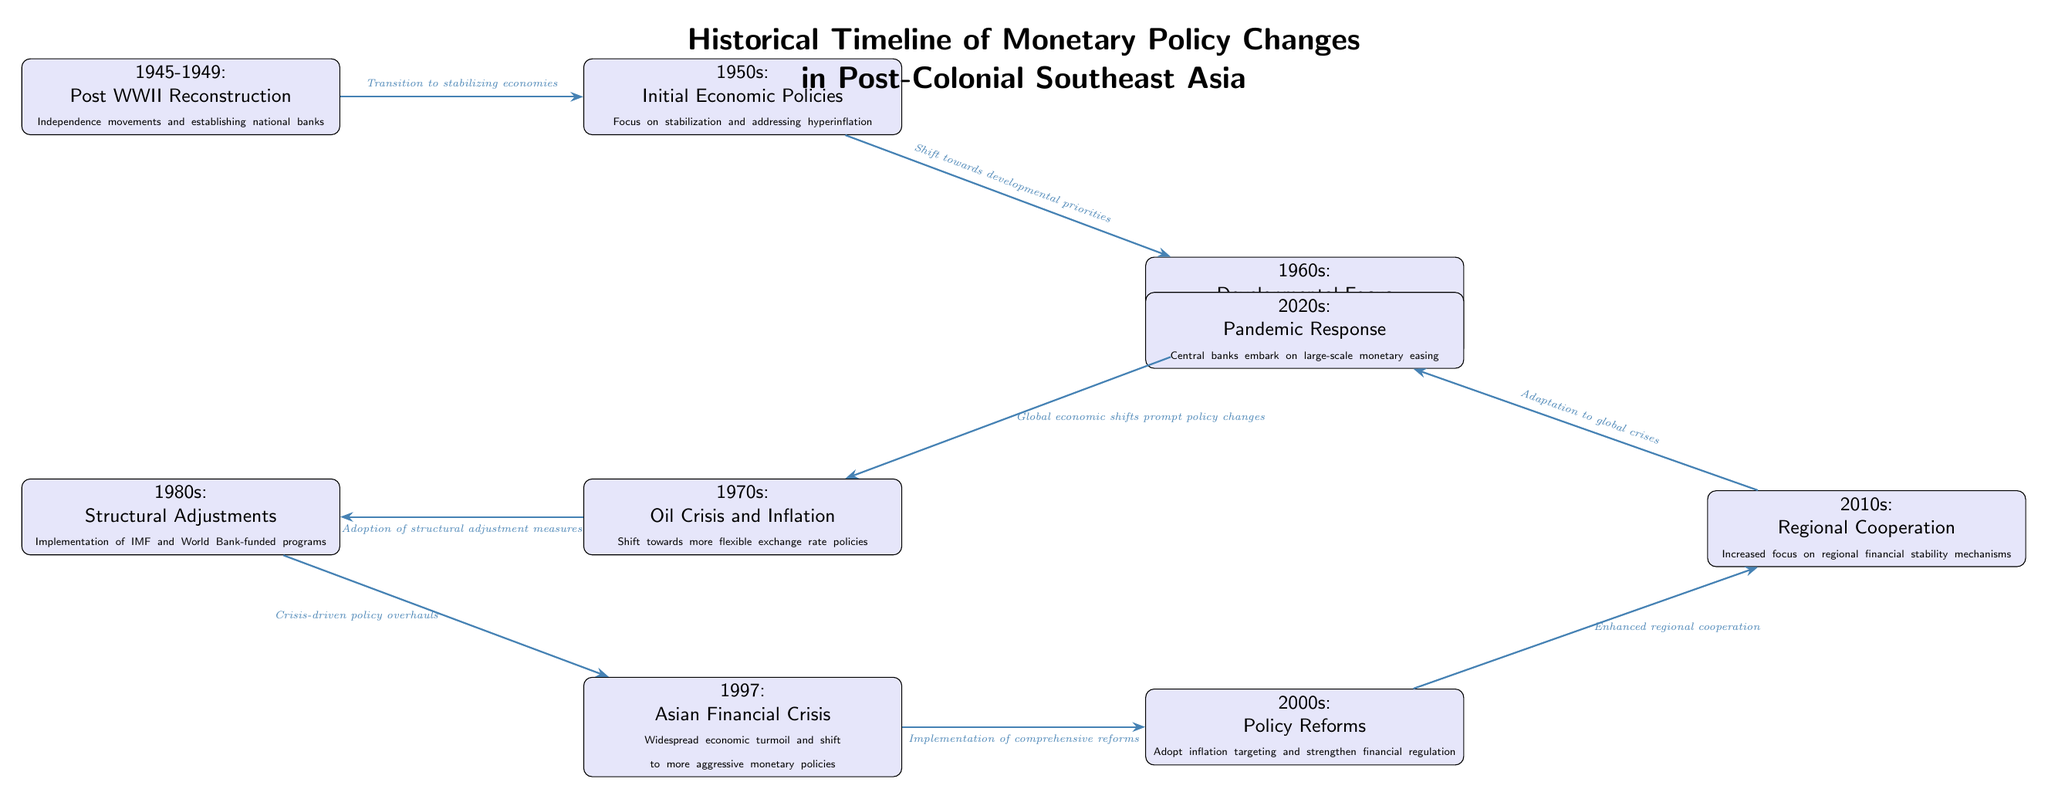What event marks the beginning of the timeline? The diagram starts with the period 1945-1949, labeled as "Post WWII Reconstruction" that discusses the independence movements and establishment of national banks.
Answer: 1945-1949 How many nodes are there in the diagram? The diagram contains a total of 9 nodes that represent different time periods and monetary policies.
Answer: 9 What was the focus of monetary policy in the 1980s? The node for the 1980s indicates "Structural Adjustments," highlighting the implementation of IMF and World Bank-funded programs as a key focus area.
Answer: Structural Adjustments Which event directly follows the Asian Financial Crisis in the timeline? The node for the Asian Financial Crisis (1997) is followed by the node for the 2000s, which emphasizes "Policy Reforms" including inflation targeting and strengthening financial regulation.
Answer: Policy Reforms What thematic shift occurs between the 1950s and 1960s? The transition from the 1950s to the 1960s shows a shift from "Initial Economic Policies" focusing on stabilization to a "Developmental Focus" aimed at supporting infrastructure through directed credit and fixed exchange rates.
Answer: Shift towards developmental priorities Which political and economic crisis is noted in the 1970s? The 1970s node discusses the "Oil Crisis and Inflation," indicating a significant crisis impacting economic policies during that period.
Answer: Oil Crisis and Inflation What connection is made between the 1997 financial crisis and policy changes? The diagram states that the Asian Financial Crisis led to "Crisis-driven policy overhauls," signifying a relationship between the crisis and subsequent monetary policy adaptations.
Answer: Crisis-driven policy overhauls What major regional development is highlighted in the 2010s? The 2010s node mentions "Regional Cooperation," indicating an increased focus on regional financial stability mechanisms following various economic challenges.
Answer: Regional Cooperation What overarching theme connects all the nodes in the diagram? The thematic flow throughout the nodes indicates the evolution of monetary policies in response to historical events and economic challenges faced by post-colonial Southeast Asian countries.
Answer: Evolution of monetary policies 